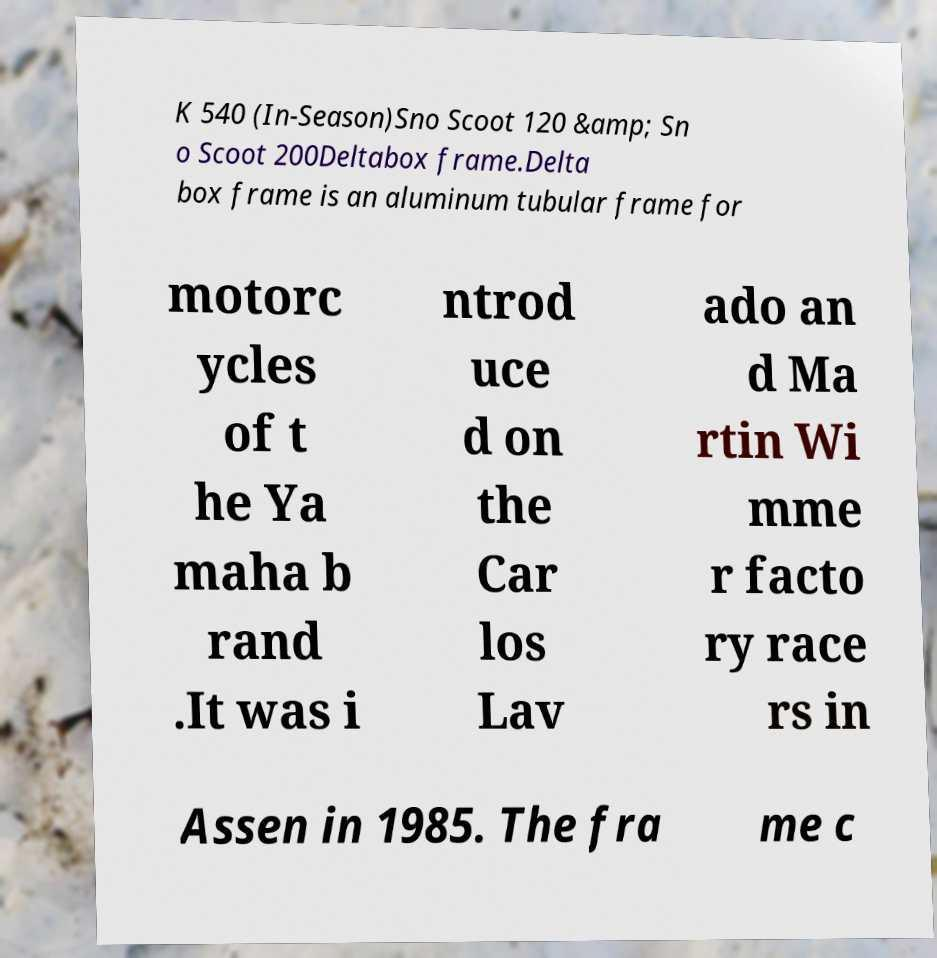Please identify and transcribe the text found in this image. K 540 (In-Season)Sno Scoot 120 &amp; Sn o Scoot 200Deltabox frame.Delta box frame is an aluminum tubular frame for motorc ycles of t he Ya maha b rand .It was i ntrod uce d on the Car los Lav ado an d Ma rtin Wi mme r facto ry race rs in Assen in 1985. The fra me c 